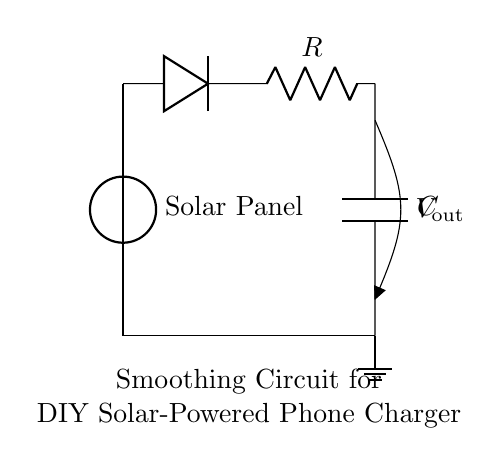What components are present in this circuit? The circuit includes a solar panel, a diode, a resistor, and a capacitor. Each component is connected in a specific arrangement to manage voltage and smooth the output.
Answer: solar panel, diode, resistor, capacitor What is the purpose of the diode? The diode is used to allow current to flow in one direction only, preventing reverse current that could damage the solar panel or other components. This is critical in protecting the circuit from incorrect voltage flow.
Answer: prevent reverse current What does the capacitor do in this circuit? The capacitor stores electrical energy and releases it when needed, helping to smooth out fluctuations in voltage caused by the fluctuating output from the solar panel. It effectively stabilizes the output voltage.
Answer: smooth output voltage What happens to the output voltage if the capacitor is removed? Removing the capacitor would result in more significant fluctuations in output voltage from the solar panel, making it less stable and potentially damaging to devices being charged.
Answer: increased voltage fluctuations What is the relationship between the resistor and capacitor in this circuit? The resistor and capacitor form an RC network that determines the time constant of the circuit, affecting how quickly the capacitor charges and discharges. The time constant is essential for smoothing the output.
Answer: RC time constant What voltage does the solar panel provide? The circuit diagram does not specify an exact voltage, but typically, a solar panel can provide around 5 to 20 volts depending on the type and conditions.
Answer: approximately 5 to 20 volts 